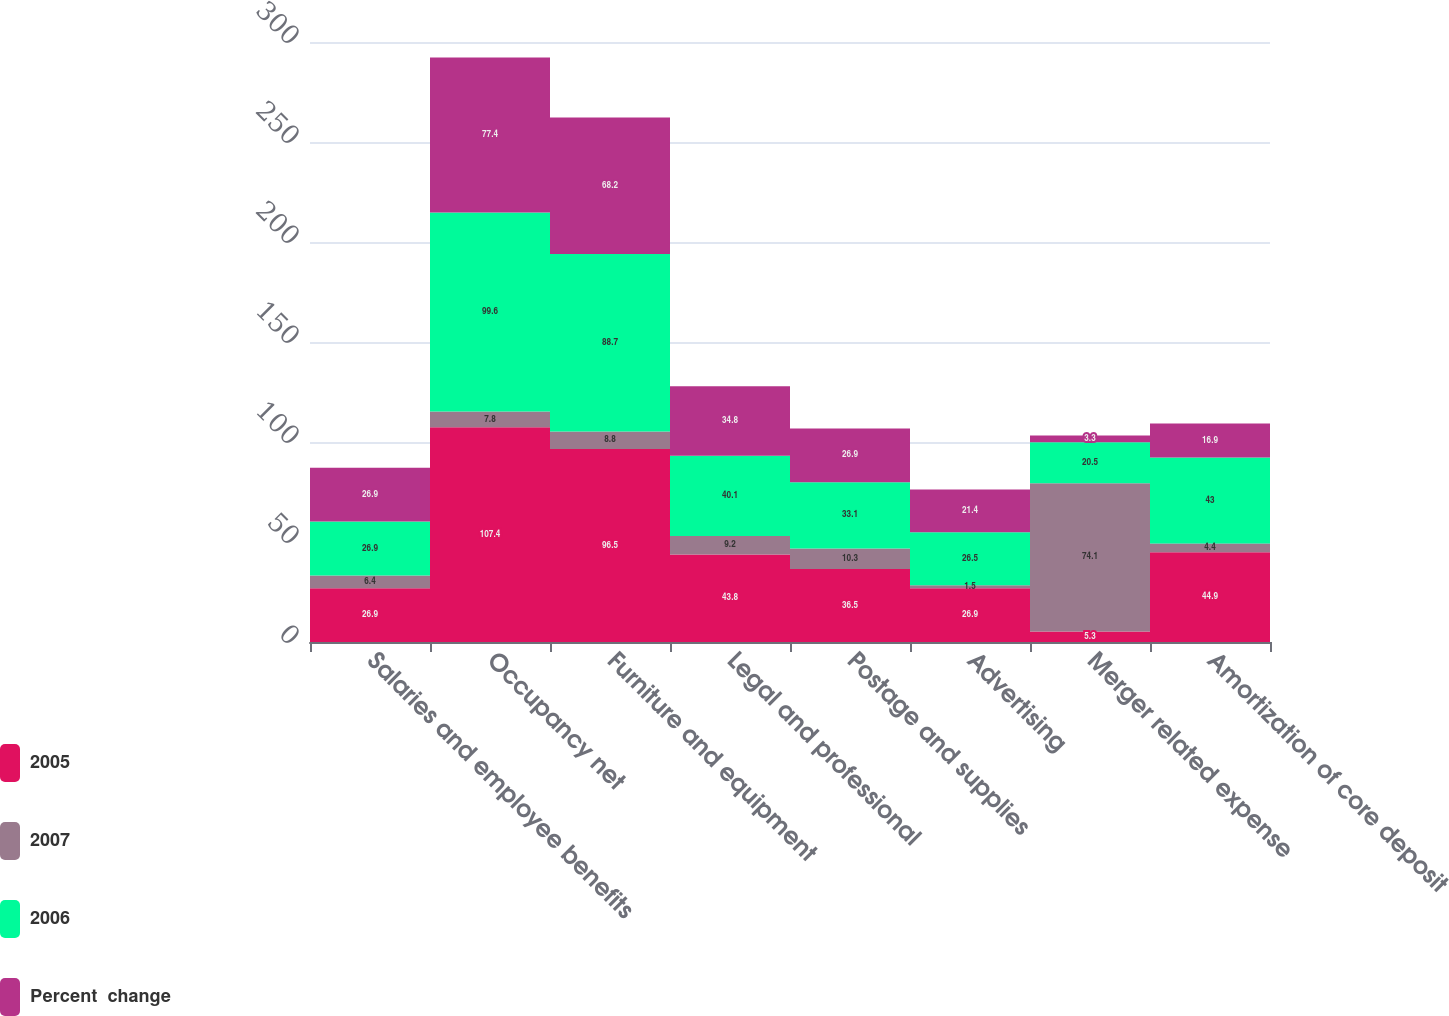<chart> <loc_0><loc_0><loc_500><loc_500><stacked_bar_chart><ecel><fcel>Salaries and employee benefits<fcel>Occupancy net<fcel>Furniture and equipment<fcel>Legal and professional<fcel>Postage and supplies<fcel>Advertising<fcel>Merger related expense<fcel>Amortization of core deposit<nl><fcel>2005<fcel>26.9<fcel>107.4<fcel>96.5<fcel>43.8<fcel>36.5<fcel>26.9<fcel>5.3<fcel>44.9<nl><fcel>2007<fcel>6.4<fcel>7.8<fcel>8.8<fcel>9.2<fcel>10.3<fcel>1.5<fcel>74.1<fcel>4.4<nl><fcel>2006<fcel>26.9<fcel>99.6<fcel>88.7<fcel>40.1<fcel>33.1<fcel>26.5<fcel>20.5<fcel>43<nl><fcel>Percent  change<fcel>26.9<fcel>77.4<fcel>68.2<fcel>34.8<fcel>26.9<fcel>21.4<fcel>3.3<fcel>16.9<nl></chart> 